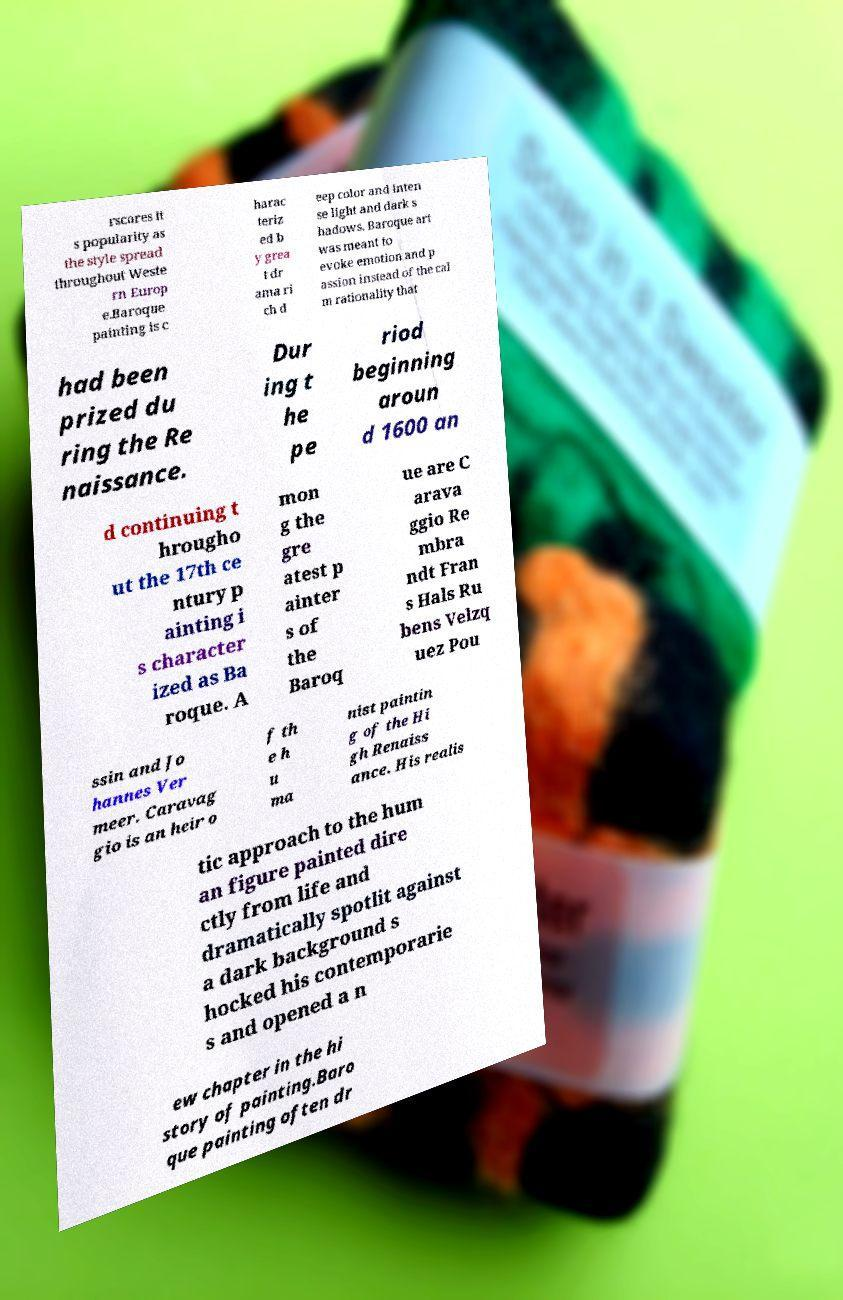Can you accurately transcribe the text from the provided image for me? rscores it s popularity as the style spread throughout Weste rn Europ e.Baroque painting is c harac teriz ed b y grea t dr ama ri ch d eep color and inten se light and dark s hadows. Baroque art was meant to evoke emotion and p assion instead of the cal m rationality that had been prized du ring the Re naissance. Dur ing t he pe riod beginning aroun d 1600 an d continuing t hrougho ut the 17th ce ntury p ainting i s character ized as Ba roque. A mon g the gre atest p ainter s of the Baroq ue are C arava ggio Re mbra ndt Fran s Hals Ru bens Velzq uez Pou ssin and Jo hannes Ver meer. Caravag gio is an heir o f th e h u ma nist paintin g of the Hi gh Renaiss ance. His realis tic approach to the hum an figure painted dire ctly from life and dramatically spotlit against a dark background s hocked his contemporarie s and opened a n ew chapter in the hi story of painting.Baro que painting often dr 